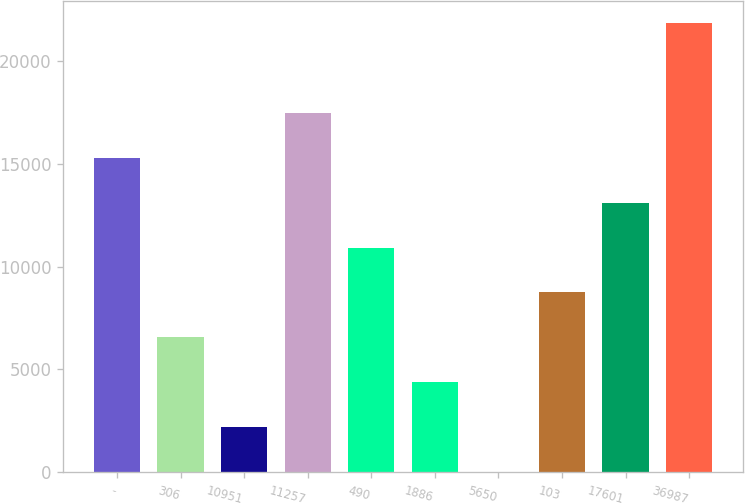<chart> <loc_0><loc_0><loc_500><loc_500><bar_chart><fcel>-<fcel>306<fcel>10951<fcel>11257<fcel>490<fcel>1886<fcel>5650<fcel>103<fcel>17601<fcel>36987<nl><fcel>15294.9<fcel>6568.1<fcel>2204.7<fcel>17476.6<fcel>10931.5<fcel>4386.4<fcel>23<fcel>8749.8<fcel>13113.2<fcel>21840<nl></chart> 